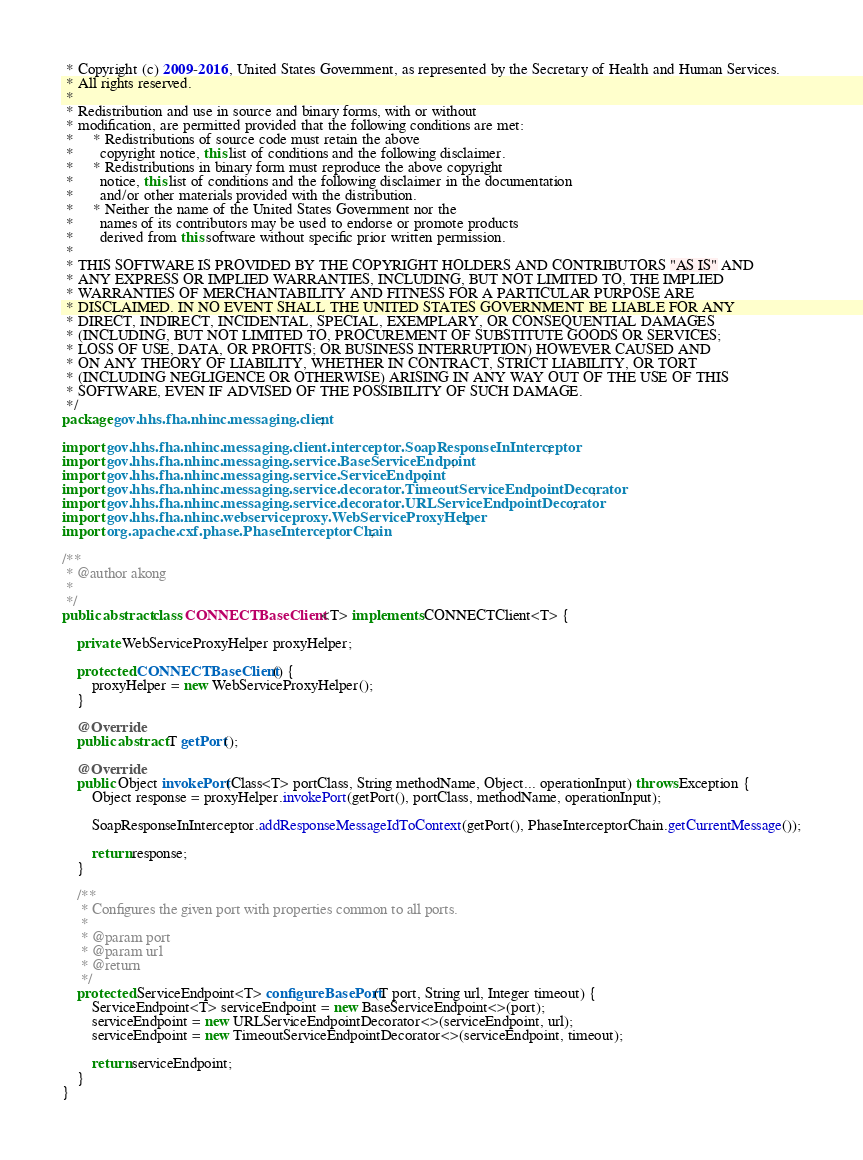<code> <loc_0><loc_0><loc_500><loc_500><_Java_> * Copyright (c) 2009-2016, United States Government, as represented by the Secretary of Health and Human Services.
 * All rights reserved.
 *
 * Redistribution and use in source and binary forms, with or without
 * modification, are permitted provided that the following conditions are met:
 *     * Redistributions of source code must retain the above
 *       copyright notice, this list of conditions and the following disclaimer.
 *     * Redistributions in binary form must reproduce the above copyright
 *       notice, this list of conditions and the following disclaimer in the documentation
 *       and/or other materials provided with the distribution.
 *     * Neither the name of the United States Government nor the
 *       names of its contributors may be used to endorse or promote products
 *       derived from this software without specific prior written permission.
 *
 * THIS SOFTWARE IS PROVIDED BY THE COPYRIGHT HOLDERS AND CONTRIBUTORS "AS IS" AND
 * ANY EXPRESS OR IMPLIED WARRANTIES, INCLUDING, BUT NOT LIMITED TO, THE IMPLIED
 * WARRANTIES OF MERCHANTABILITY AND FITNESS FOR A PARTICULAR PURPOSE ARE
 * DISCLAIMED. IN NO EVENT SHALL THE UNITED STATES GOVERNMENT BE LIABLE FOR ANY
 * DIRECT, INDIRECT, INCIDENTAL, SPECIAL, EXEMPLARY, OR CONSEQUENTIAL DAMAGES
 * (INCLUDING, BUT NOT LIMITED TO, PROCUREMENT OF SUBSTITUTE GOODS OR SERVICES;
 * LOSS OF USE, DATA, OR PROFITS; OR BUSINESS INTERRUPTION) HOWEVER CAUSED AND
 * ON ANY THEORY OF LIABILITY, WHETHER IN CONTRACT, STRICT LIABILITY, OR TORT
 * (INCLUDING NEGLIGENCE OR OTHERWISE) ARISING IN ANY WAY OUT OF THE USE OF THIS
 * SOFTWARE, EVEN IF ADVISED OF THE POSSIBILITY OF SUCH DAMAGE.
 */
package gov.hhs.fha.nhinc.messaging.client;

import gov.hhs.fha.nhinc.messaging.client.interceptor.SoapResponseInInterceptor;
import gov.hhs.fha.nhinc.messaging.service.BaseServiceEndpoint;
import gov.hhs.fha.nhinc.messaging.service.ServiceEndpoint;
import gov.hhs.fha.nhinc.messaging.service.decorator.TimeoutServiceEndpointDecorator;
import gov.hhs.fha.nhinc.messaging.service.decorator.URLServiceEndpointDecorator;
import gov.hhs.fha.nhinc.webserviceproxy.WebServiceProxyHelper;
import org.apache.cxf.phase.PhaseInterceptorChain;

/**
 * @author akong
 *
 */
public abstract class CONNECTBaseClient<T> implements CONNECTClient<T> {

    private WebServiceProxyHelper proxyHelper;

    protected CONNECTBaseClient() {
        proxyHelper = new WebServiceProxyHelper();
    }

    @Override
    public abstract T getPort();

    @Override
    public Object invokePort(Class<T> portClass, String methodName, Object... operationInput) throws Exception {
        Object response = proxyHelper.invokePort(getPort(), portClass, methodName, operationInput);

        SoapResponseInInterceptor.addResponseMessageIdToContext(getPort(), PhaseInterceptorChain.getCurrentMessage());

        return response;
    }

    /**
     * Configures the given port with properties common to all ports.
     *
     * @param port
     * @param url
     * @return
     */
    protected ServiceEndpoint<T> configureBasePort(T port, String url, Integer timeout) {
        ServiceEndpoint<T> serviceEndpoint = new BaseServiceEndpoint<>(port);
        serviceEndpoint = new URLServiceEndpointDecorator<>(serviceEndpoint, url);
        serviceEndpoint = new TimeoutServiceEndpointDecorator<>(serviceEndpoint, timeout);

        return serviceEndpoint;
    }
}
</code> 